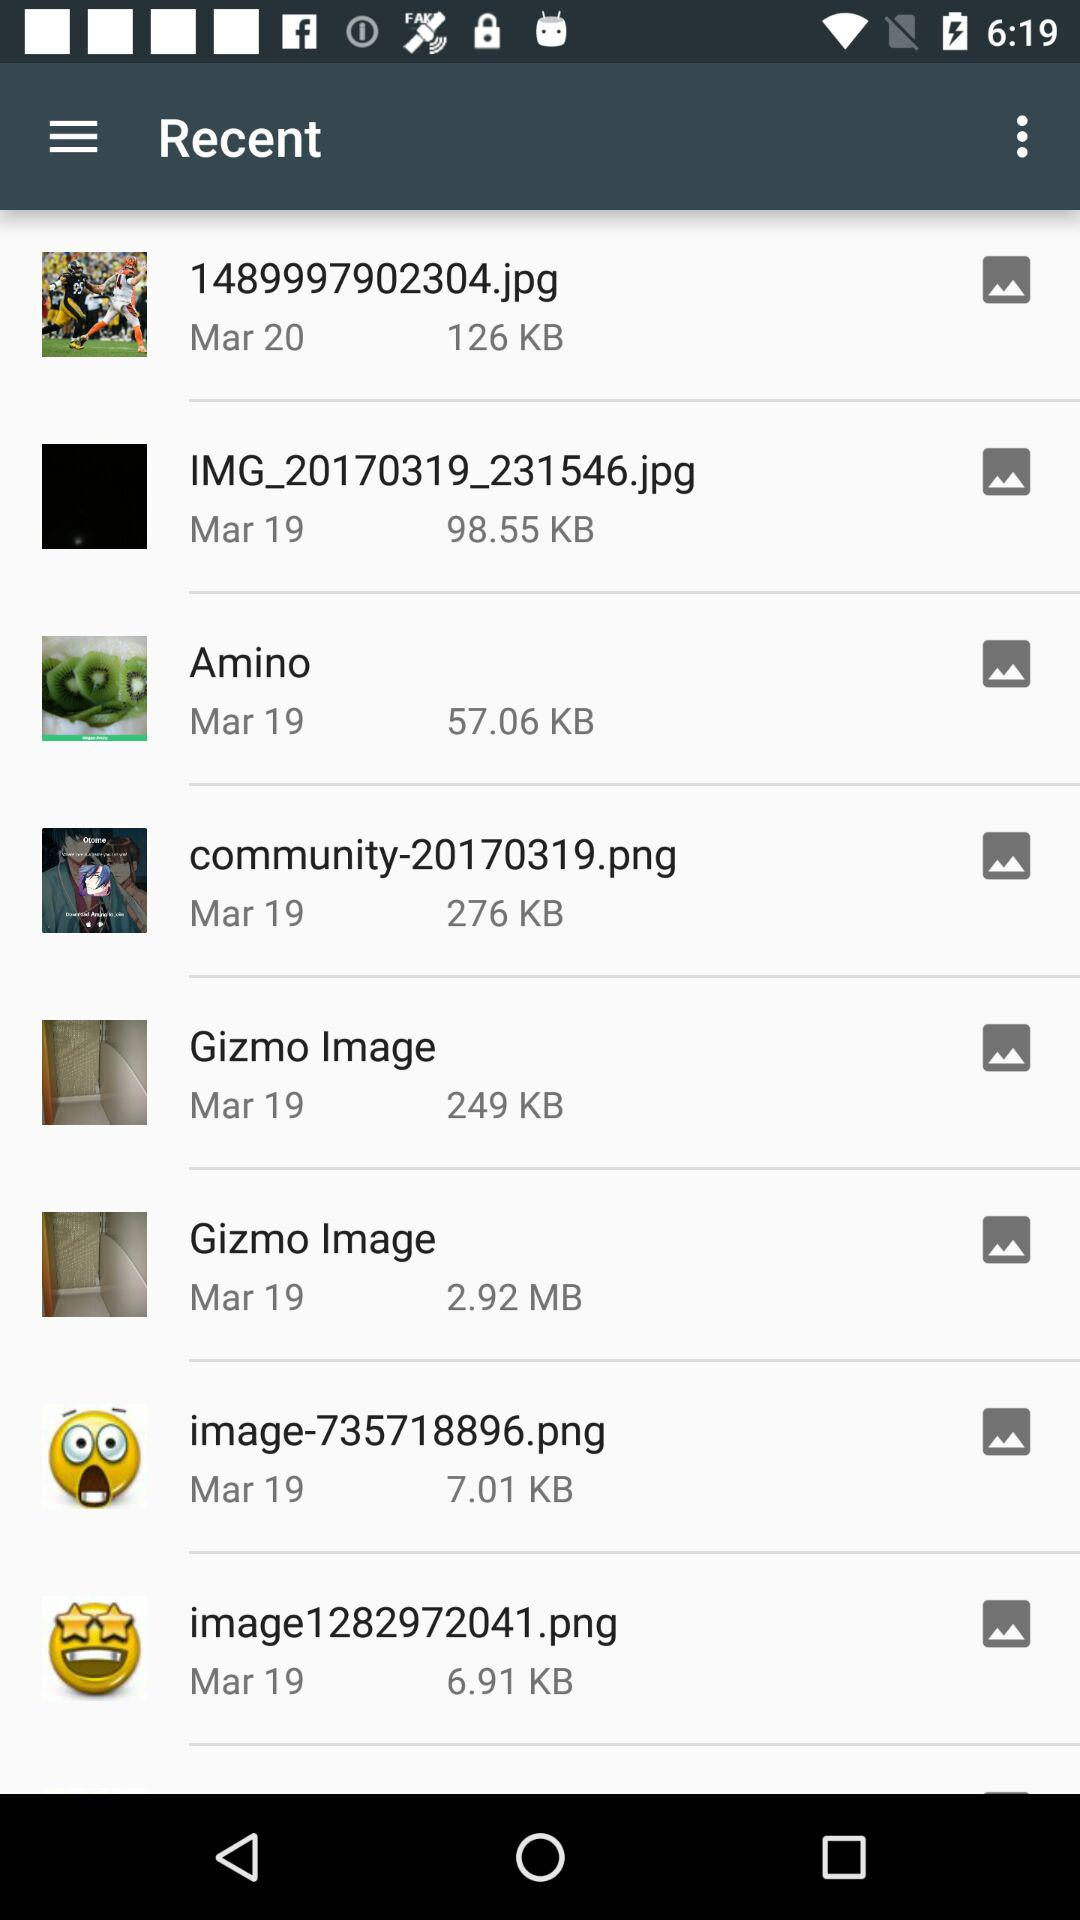What is the size of "image-735718896.png" in KB? The size of "image-735718896.png" is 7.01 KB. 